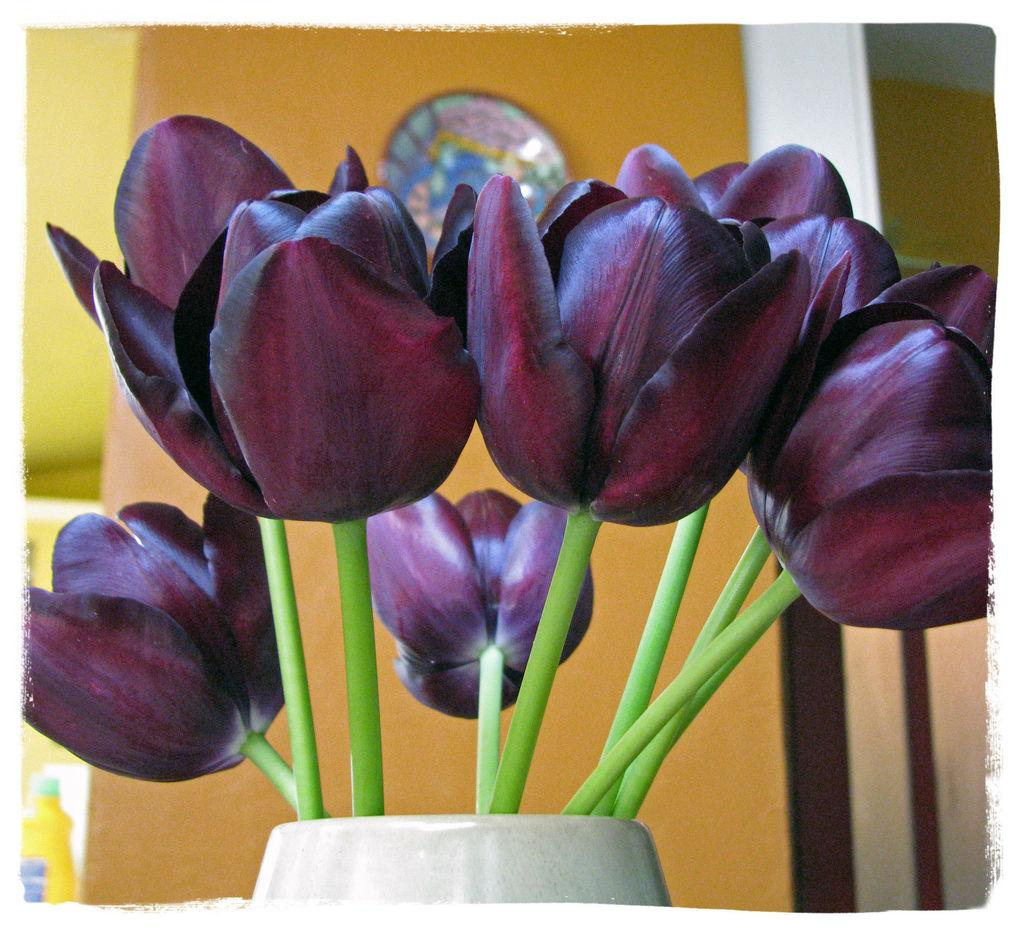What is the color of the wall in the image? The wall in the image is yellow. What can be seen attached to the yellow wall? There is a colorful object attached to the yellow wall. What is near the yellow wall? There is a white pot with flowers near the yellow wall. What is present on the surface in the image? There are objects on the surface in the image. What is the amount of debt owed by the colorful object in the image? There is no indication of debt in the image, as it features a colorful object attached to a yellow wall and a white pot with flowers. 